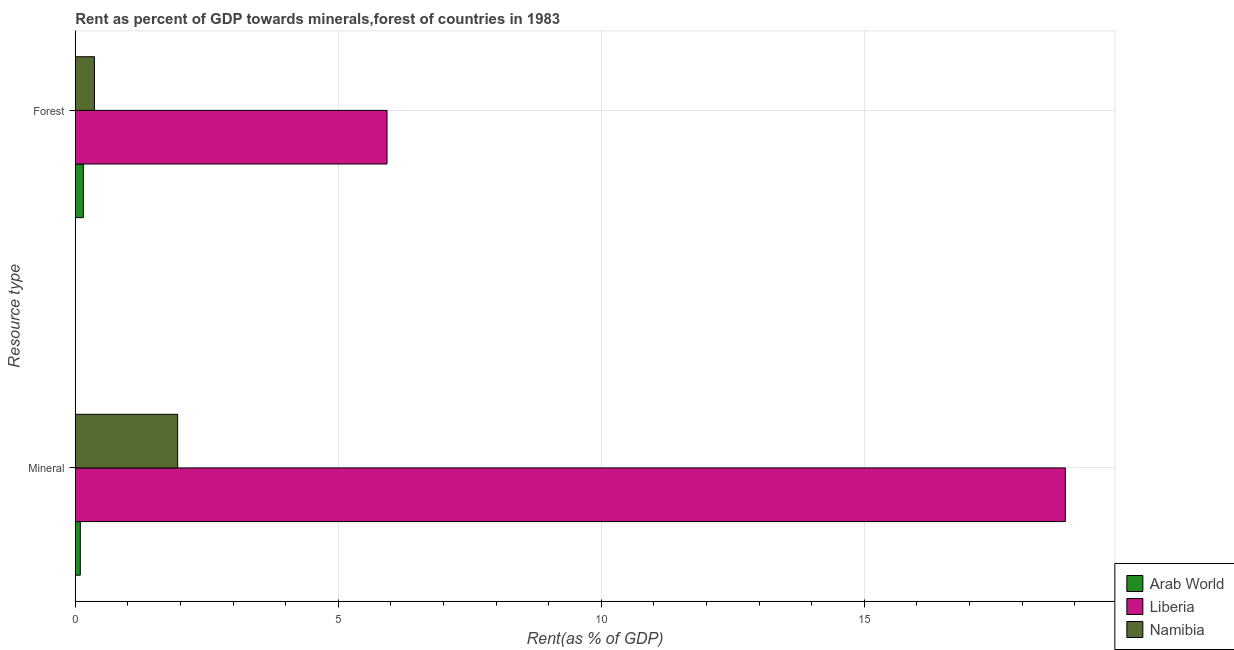Are the number of bars on each tick of the Y-axis equal?
Make the answer very short. Yes. How many bars are there on the 1st tick from the top?
Your response must be concise. 3. What is the label of the 2nd group of bars from the top?
Keep it short and to the point. Mineral. What is the forest rent in Liberia?
Your answer should be very brief. 5.93. Across all countries, what is the maximum forest rent?
Keep it short and to the point. 5.93. Across all countries, what is the minimum forest rent?
Keep it short and to the point. 0.15. In which country was the forest rent maximum?
Make the answer very short. Liberia. In which country was the mineral rent minimum?
Your answer should be very brief. Arab World. What is the total mineral rent in the graph?
Offer a terse response. 20.86. What is the difference between the mineral rent in Liberia and that in Arab World?
Provide a short and direct response. 18.73. What is the difference between the forest rent in Liberia and the mineral rent in Namibia?
Make the answer very short. 3.98. What is the average forest rent per country?
Your answer should be compact. 2.15. What is the difference between the forest rent and mineral rent in Namibia?
Offer a very short reply. -1.58. What is the ratio of the mineral rent in Liberia to that in Namibia?
Provide a succinct answer. 9.67. What does the 2nd bar from the top in Mineral represents?
Keep it short and to the point. Liberia. What does the 2nd bar from the bottom in Forest represents?
Your response must be concise. Liberia. How many bars are there?
Provide a short and direct response. 6. How many countries are there in the graph?
Your answer should be compact. 3. What is the difference between two consecutive major ticks on the X-axis?
Your response must be concise. 5. Are the values on the major ticks of X-axis written in scientific E-notation?
Keep it short and to the point. No. Does the graph contain any zero values?
Give a very brief answer. No. Where does the legend appear in the graph?
Provide a short and direct response. Bottom right. How are the legend labels stacked?
Your answer should be very brief. Vertical. What is the title of the graph?
Give a very brief answer. Rent as percent of GDP towards minerals,forest of countries in 1983. Does "East Asia (developing only)" appear as one of the legend labels in the graph?
Your answer should be compact. No. What is the label or title of the X-axis?
Your answer should be very brief. Rent(as % of GDP). What is the label or title of the Y-axis?
Offer a terse response. Resource type. What is the Rent(as % of GDP) in Arab World in Mineral?
Your answer should be very brief. 0.1. What is the Rent(as % of GDP) in Liberia in Mineral?
Offer a very short reply. 18.82. What is the Rent(as % of GDP) in Namibia in Mineral?
Offer a terse response. 1.95. What is the Rent(as % of GDP) of Arab World in Forest?
Offer a very short reply. 0.15. What is the Rent(as % of GDP) in Liberia in Forest?
Your answer should be very brief. 5.93. What is the Rent(as % of GDP) in Namibia in Forest?
Your answer should be very brief. 0.36. Across all Resource type, what is the maximum Rent(as % of GDP) of Arab World?
Give a very brief answer. 0.15. Across all Resource type, what is the maximum Rent(as % of GDP) of Liberia?
Make the answer very short. 18.82. Across all Resource type, what is the maximum Rent(as % of GDP) of Namibia?
Offer a very short reply. 1.95. Across all Resource type, what is the minimum Rent(as % of GDP) of Arab World?
Your answer should be very brief. 0.1. Across all Resource type, what is the minimum Rent(as % of GDP) in Liberia?
Keep it short and to the point. 5.93. Across all Resource type, what is the minimum Rent(as % of GDP) in Namibia?
Offer a terse response. 0.36. What is the total Rent(as % of GDP) in Arab World in the graph?
Offer a terse response. 0.25. What is the total Rent(as % of GDP) of Liberia in the graph?
Provide a succinct answer. 24.75. What is the total Rent(as % of GDP) in Namibia in the graph?
Make the answer very short. 2.31. What is the difference between the Rent(as % of GDP) in Arab World in Mineral and that in Forest?
Your answer should be very brief. -0.06. What is the difference between the Rent(as % of GDP) of Liberia in Mineral and that in Forest?
Ensure brevity in your answer.  12.9. What is the difference between the Rent(as % of GDP) of Namibia in Mineral and that in Forest?
Make the answer very short. 1.58. What is the difference between the Rent(as % of GDP) of Arab World in Mineral and the Rent(as % of GDP) of Liberia in Forest?
Make the answer very short. -5.83. What is the difference between the Rent(as % of GDP) of Arab World in Mineral and the Rent(as % of GDP) of Namibia in Forest?
Keep it short and to the point. -0.27. What is the difference between the Rent(as % of GDP) in Liberia in Mineral and the Rent(as % of GDP) in Namibia in Forest?
Provide a short and direct response. 18.46. What is the average Rent(as % of GDP) of Arab World per Resource type?
Give a very brief answer. 0.12. What is the average Rent(as % of GDP) of Liberia per Resource type?
Your answer should be compact. 12.37. What is the average Rent(as % of GDP) in Namibia per Resource type?
Your answer should be compact. 1.16. What is the difference between the Rent(as % of GDP) in Arab World and Rent(as % of GDP) in Liberia in Mineral?
Provide a short and direct response. -18.73. What is the difference between the Rent(as % of GDP) in Arab World and Rent(as % of GDP) in Namibia in Mineral?
Offer a very short reply. -1.85. What is the difference between the Rent(as % of GDP) of Liberia and Rent(as % of GDP) of Namibia in Mineral?
Your answer should be compact. 16.88. What is the difference between the Rent(as % of GDP) in Arab World and Rent(as % of GDP) in Liberia in Forest?
Offer a terse response. -5.77. What is the difference between the Rent(as % of GDP) in Arab World and Rent(as % of GDP) in Namibia in Forest?
Keep it short and to the point. -0.21. What is the difference between the Rent(as % of GDP) of Liberia and Rent(as % of GDP) of Namibia in Forest?
Keep it short and to the point. 5.56. What is the ratio of the Rent(as % of GDP) of Arab World in Mineral to that in Forest?
Your answer should be very brief. 0.62. What is the ratio of the Rent(as % of GDP) in Liberia in Mineral to that in Forest?
Keep it short and to the point. 3.18. What is the ratio of the Rent(as % of GDP) of Namibia in Mineral to that in Forest?
Your answer should be compact. 5.34. What is the difference between the highest and the second highest Rent(as % of GDP) in Arab World?
Keep it short and to the point. 0.06. What is the difference between the highest and the second highest Rent(as % of GDP) in Liberia?
Your answer should be very brief. 12.9. What is the difference between the highest and the second highest Rent(as % of GDP) in Namibia?
Make the answer very short. 1.58. What is the difference between the highest and the lowest Rent(as % of GDP) in Arab World?
Make the answer very short. 0.06. What is the difference between the highest and the lowest Rent(as % of GDP) in Liberia?
Give a very brief answer. 12.9. What is the difference between the highest and the lowest Rent(as % of GDP) of Namibia?
Your answer should be very brief. 1.58. 